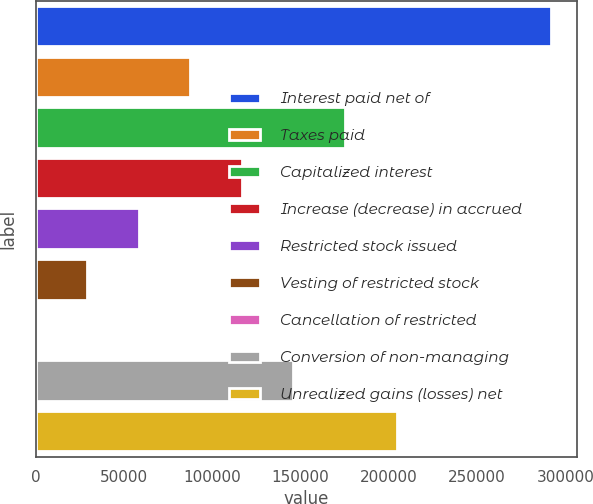Convert chart. <chart><loc_0><loc_0><loc_500><loc_500><bar_chart><fcel>Interest paid net of<fcel>Taxes paid<fcel>Capitalized interest<fcel>Increase (decrease) in accrued<fcel>Restricted stock issued<fcel>Vesting of restricted stock<fcel>Cancellation of restricted<fcel>Conversion of non-managing<fcel>Unrealized gains (losses) net<nl><fcel>291936<fcel>87617.9<fcel>175183<fcel>116806<fcel>58429.6<fcel>29241.3<fcel>53<fcel>145994<fcel>204371<nl></chart> 